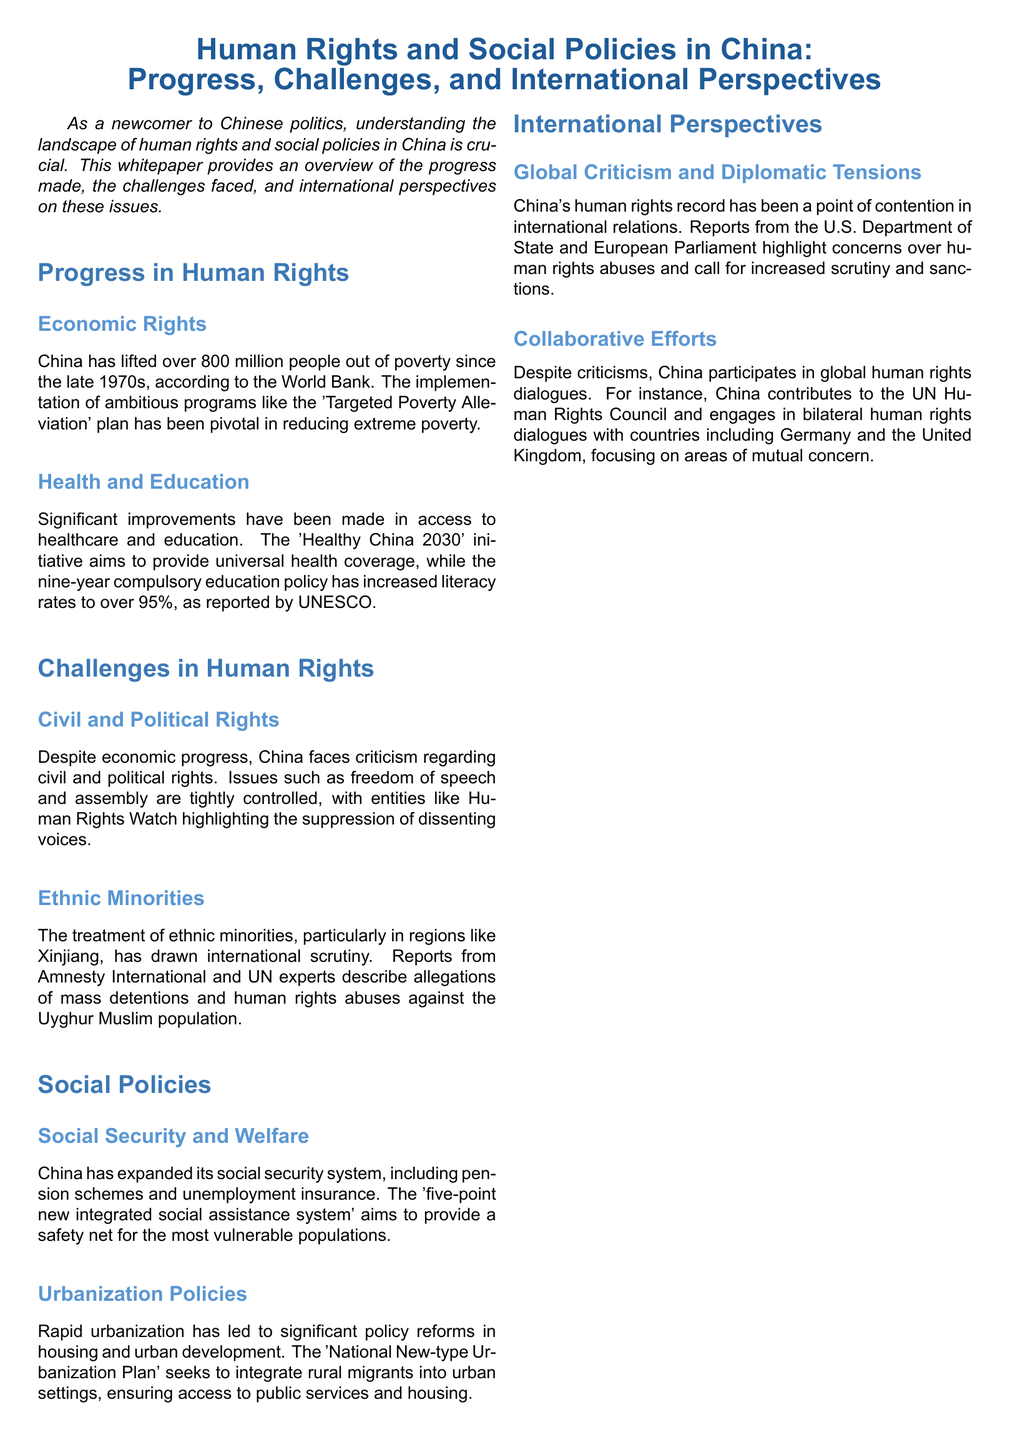What is the title of the whitepaper? The title is stated at the beginning of the document and summarizes the main topics covered.
Answer: Human Rights and Social Policies in China: Progress, Challenges, and International Perspectives How many people have been lifted out of poverty since the late 1970s? The document provides a specific figure regarding the poverty alleviation achievements in China.
Answer: Over 800 million What initiative aims to provide universal health coverage? The document mentions a specific initiative focused on health improvement in China.
Answer: Healthy China 2030 What is the literacy rate mentioned in the document? The document cites a specific percentage that indicates the improvement in education.
Answer: Over 95% What are the entities highlighting the suppression of dissenting voices? The document refers to organizations that provide commentary on civil and political rights in China.
Answer: Human Rights Watch What is the name of the system that aims to provide a safety net for the most vulnerable populations? The document describes a specific social security system designed for assistance.
Answer: five-point new integrated social assistance system Which ethnic minority group is specifically mentioned regarding human rights abuses in the document? The document identifies a particular ethnic group facing scrutiny and alleged abuses in China.
Answer: Uyghur Muslim What type of plan seeks to integrate rural migrants into urban settings? The document describes a national plan related to urbanization policy reforms.
Answer: National New-type Urbanization Plan What international organization does China contribute to regarding human rights? The document mentions an organization where China participates in human rights discussions and dialogues.
Answer: UN Human Rights Council 